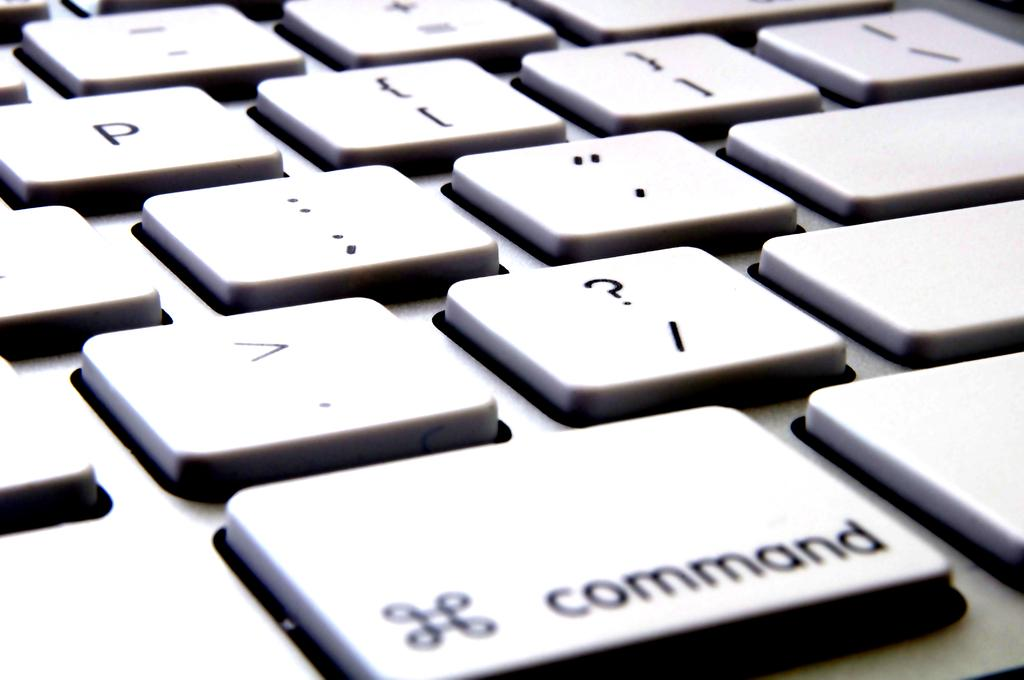Provide a one-sentence caption for the provided image. The command key is the largest key in this photo of a keyboard. 